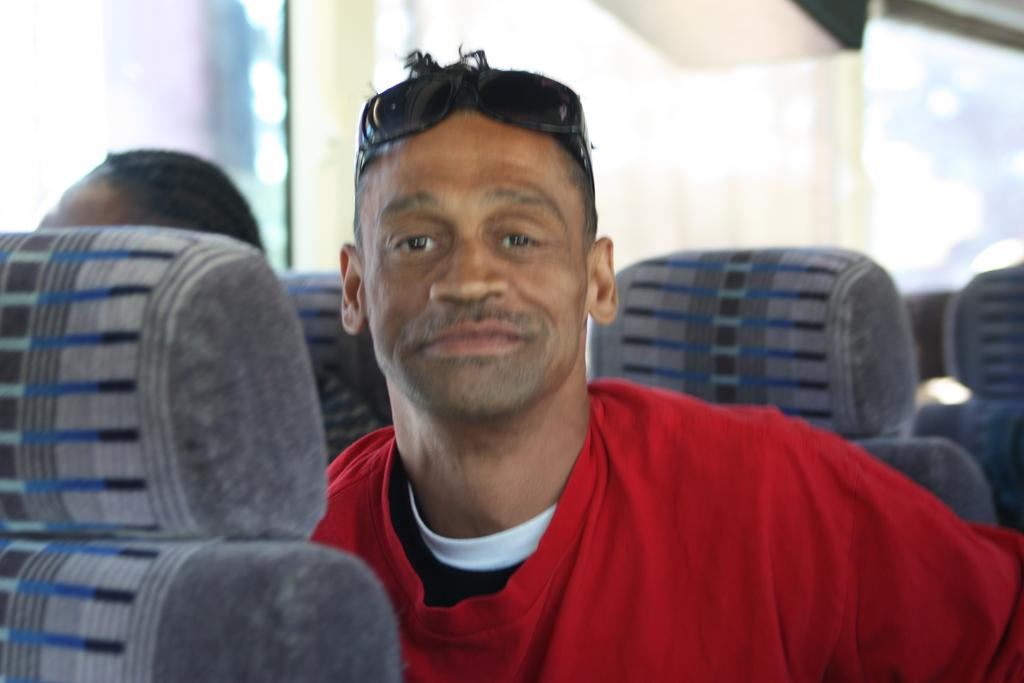What is happening in the foreground of the image? There are people sitting in the foreground of the image. Where is the image taken? The image is taken inside a bus. What type of quince is being used as a cup by the people sitting in the image? There is no quince present in the image, nor is it being used as a cup. 